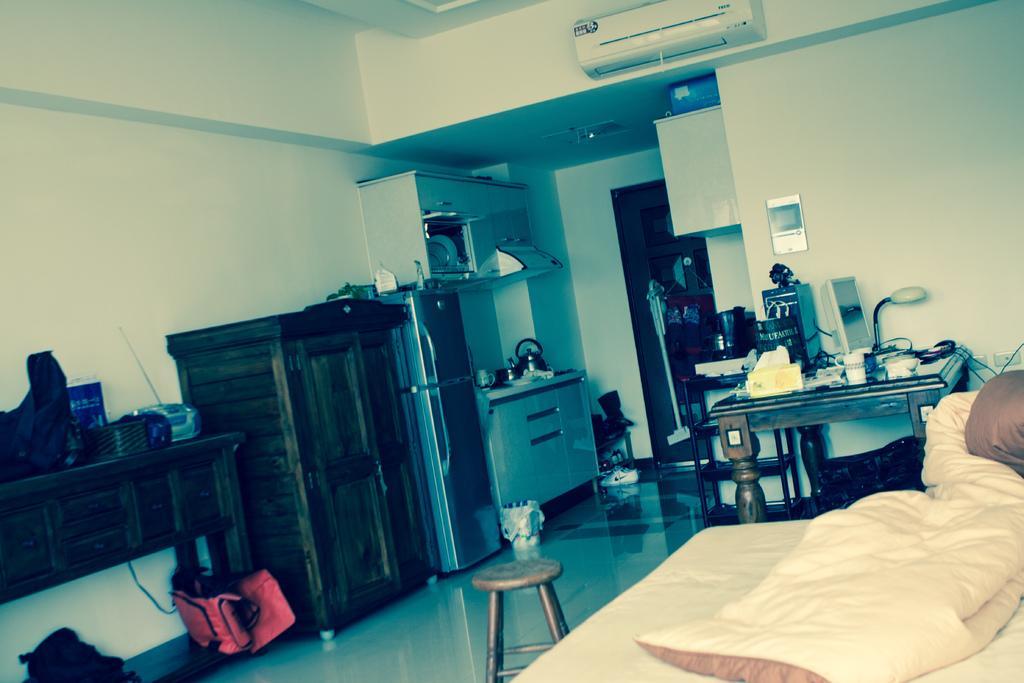Describe this image in one or two sentences. This picture is an inside view of a room. On the right side of the image we can see a bed, blanket, table, wall. On the table we can see lamp, screen, tissue papers box and some other objects. On the left side of the image we can see the wall, cupboard, refrigerator, bags, vessels, tables. On the table we can see the bags, boxes and some other objects. In the background of the image we can see air conditioner, board, wiper, plates and some other objects. At the bottom of the image we can see the floor, table. At the top of the image we can see the roof. 